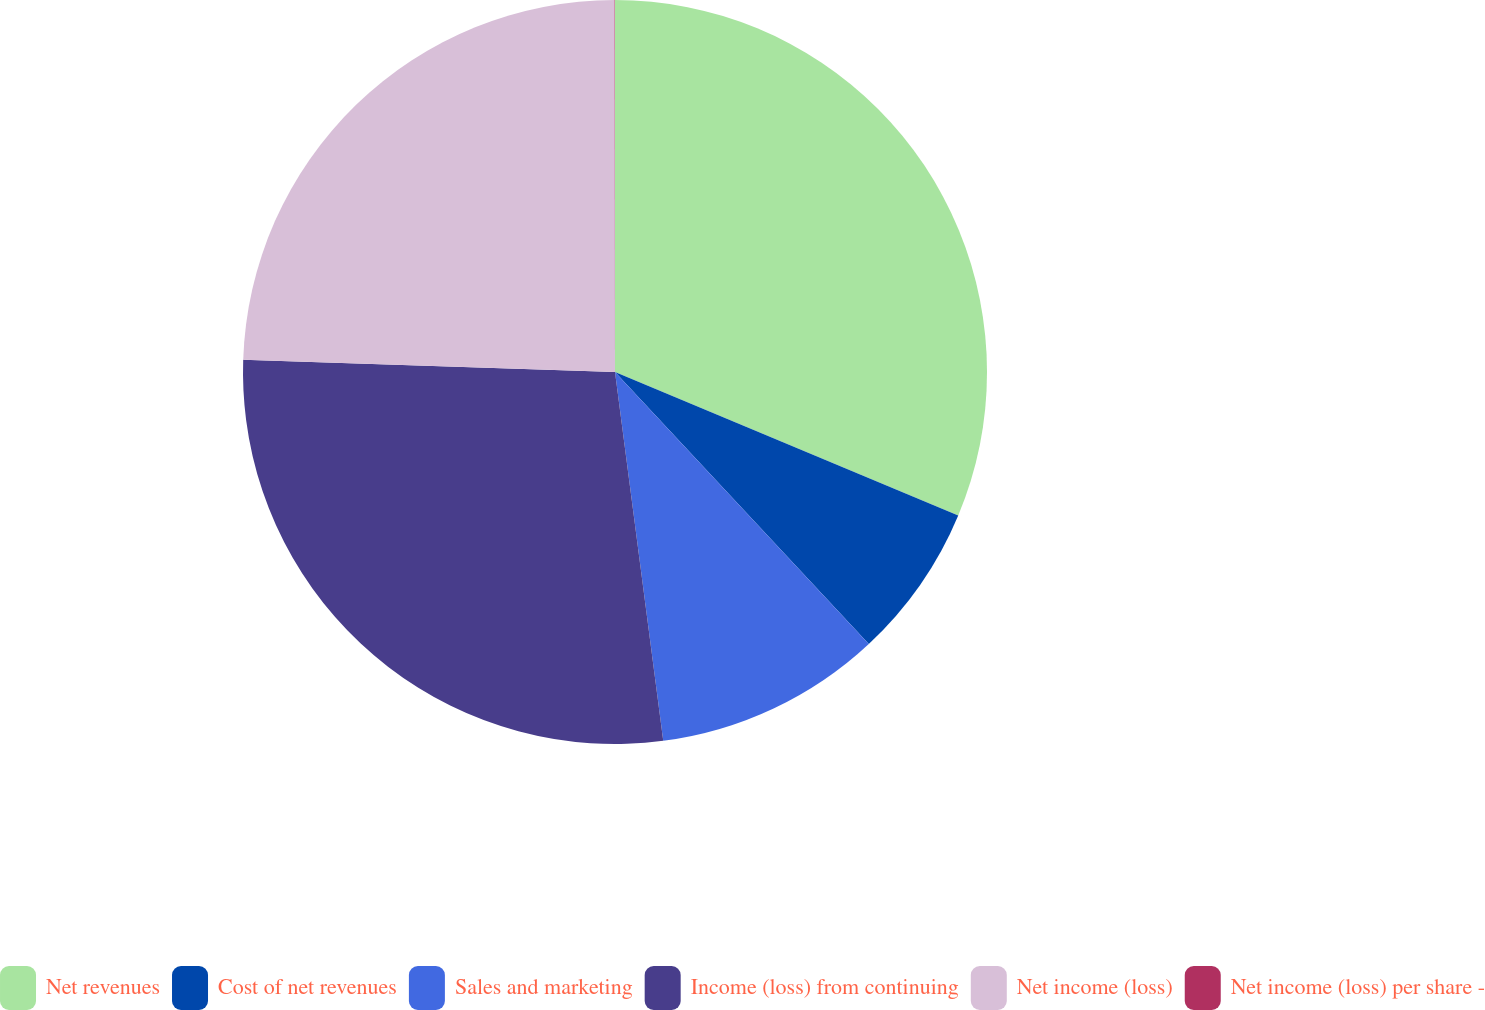Convert chart to OTSL. <chart><loc_0><loc_0><loc_500><loc_500><pie_chart><fcel>Net revenues<fcel>Cost of net revenues<fcel>Sales and marketing<fcel>Income (loss) from continuing<fcel>Net income (loss)<fcel>Net income (loss) per share -<nl><fcel>31.3%<fcel>6.75%<fcel>9.88%<fcel>27.59%<fcel>24.46%<fcel>0.02%<nl></chart> 